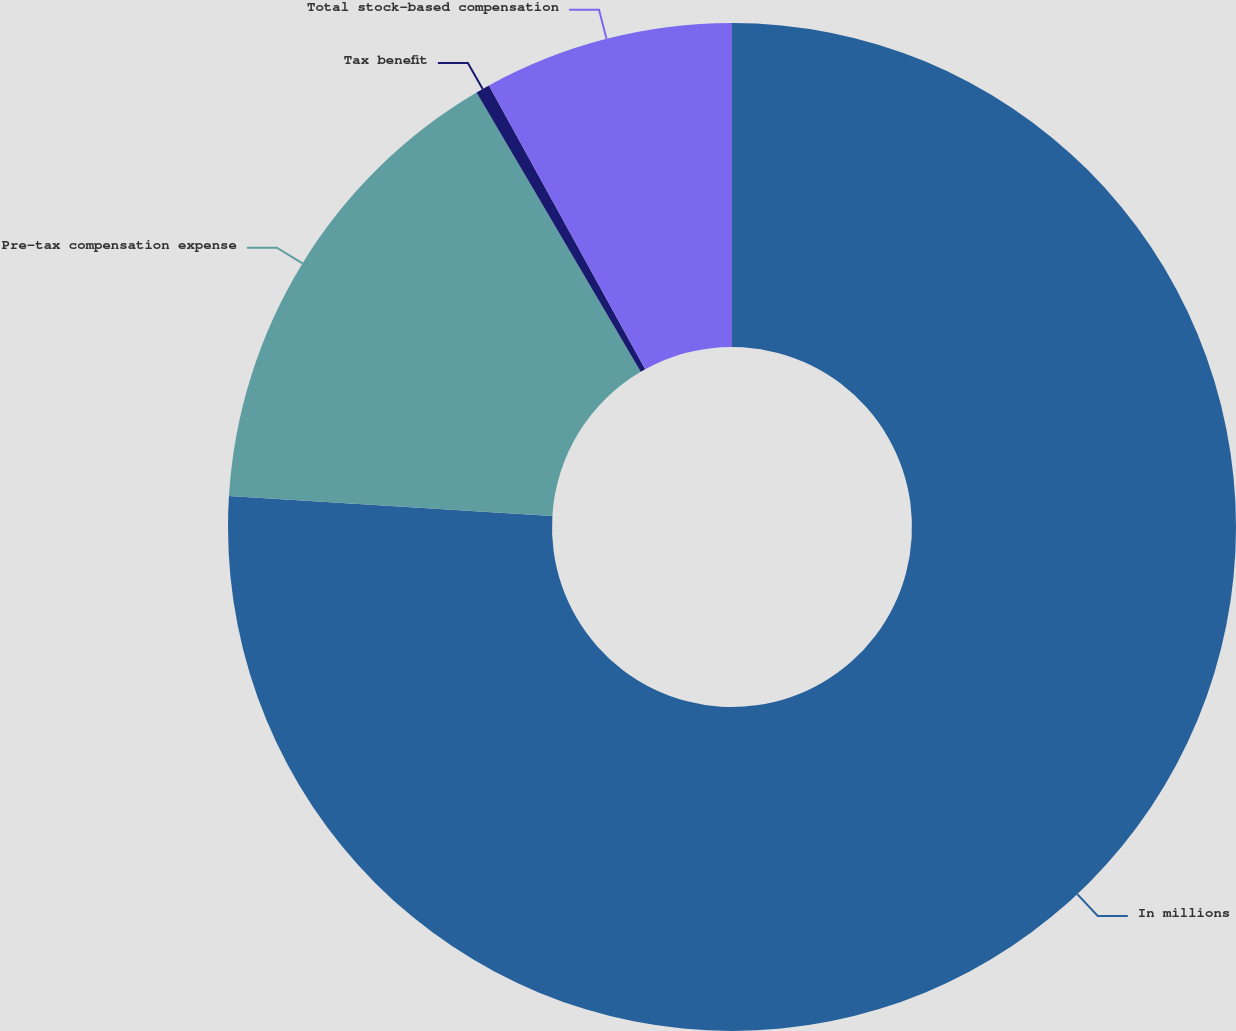Convert chart to OTSL. <chart><loc_0><loc_0><loc_500><loc_500><pie_chart><fcel>In millions<fcel>Pre-tax compensation expense<fcel>Tax benefit<fcel>Total stock-based compensation<nl><fcel>75.98%<fcel>15.56%<fcel>0.45%<fcel>8.01%<nl></chart> 